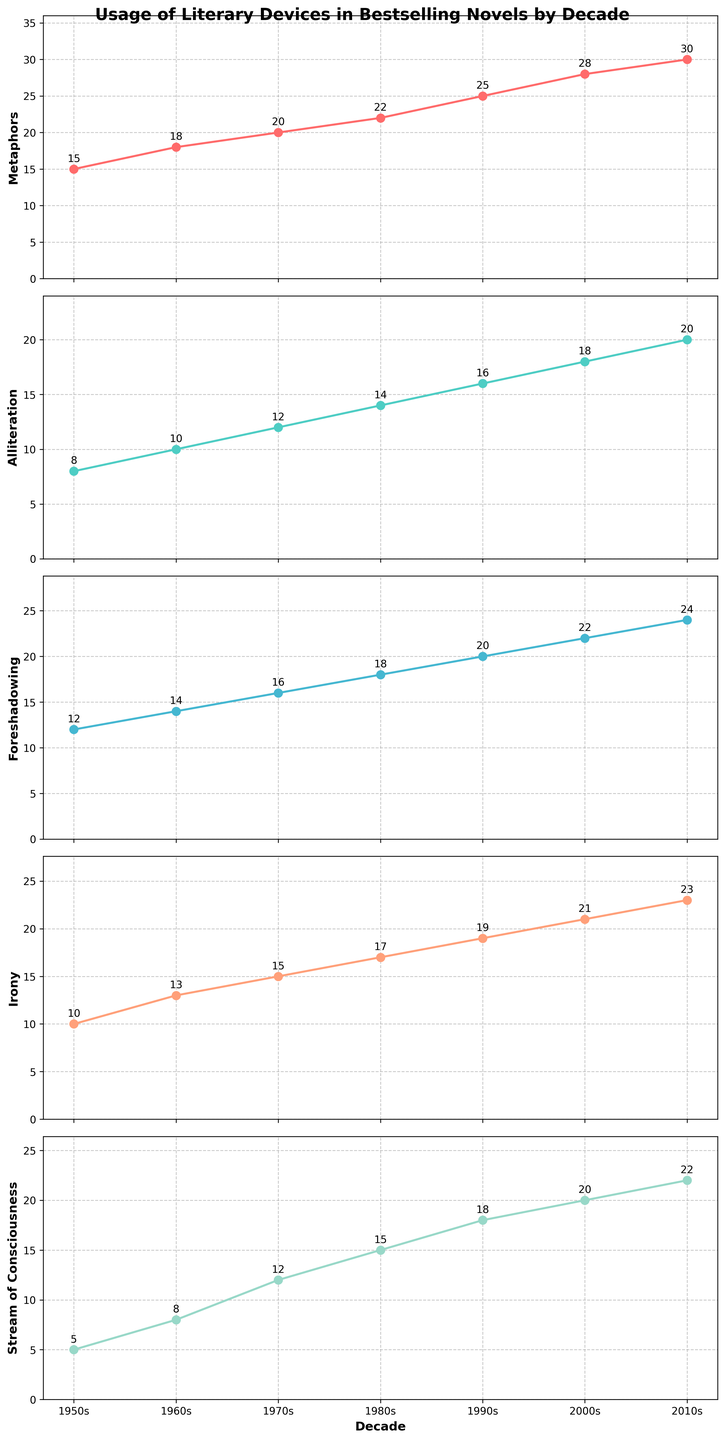What is the title of the figure? The title of the figure is displayed prominently at the top of the plot. It says "Usage of Literary Devices in Bestselling Novels by Decade."
Answer: Usage of Literary Devices in Bestselling Novels by Decade How many subplots are there in the figure? The figure is composed of five distinct vertical subplots stacked on top of each other.
Answer: 5 Which literary device shows the greatest increase between the 1950s and the 2010s? By comparing the values from the 1950s and 2010s in each subplot, we can see that "Metaphors" increased from 15 to 30, "Alliteration" from 8 to 20, "Foreshadowing" from 12 to 24, "Irony" from 10 to 23, and "Stream of Consciousness" from 5 to 22. The greatest increase is 15 (30 - 15), which is for "Metaphors."
Answer: Metaphors What decade shows the highest usage of alliteration? By looking at the "Alliteration" subplot, the line reaches its peak at 20 in the 2010s.
Answer: 2010s In which decade is the difference between the usage of Irony and Metaphors the greatest? To determine this, we need to compare the differences for each decade. The differences are: 1950s (15 - 10 = 5), 1960s (18 - 13 = 5), 1970s (20 - 15 = 5), 1980s (22 - 17 = 5), 1990s (25 - 19 = 6), 2000s (28 - 21 = 7), 2010s (30 - 23 = 7). The greatest difference is in the 2000s and 2010s, both with 7.
Answer: 2000s and 2010s What is the sum of Foreshadowing instances from 1950s to 1980s? Sum the values from the "Foreshadowing" subplot for the 1950s, 1960s, 1970s, and 1980s: 12 + 14 + 16 + 18 = 60.
Answer: 60 Which literary device had the least usage in the 1980s? Inspect the values for the 1980s in each subplot. The values are: Metaphors (22), Alliteration (14), Foreshadowing (18), Irony (17), Stream of Consciousness (15). The smallest value is 14 for Alliteration.
Answer: Alliteration What is the average usage of Stream of Consciousness across all decades? Sum the usage values for "Stream of Consciousness" for all decades and divide by the number of decades: (5 + 8 + 12 + 15 + 18 + 20 + 22) / 7 = 100 / 7 ≈ 14.29.
Answer: 14.29 In the 2000s, which literary device had usage closest to the average of all devices' usages that decade? First, calculate the average usage for the 2000s: (28 + 18 + 22 + 21 + 20) / 5 = 109 / 5 = 21.8. Comparing the individual values to 21.8, "Irony" (21) is the closest.
Answer: Irony How does the usage of Irony in the 1990s compare to the usage of Stream of Consciousness in the 2010s? From the figure, Irony in the 1990s has a value of 19, while Stream of Consciousness in the 2010s has a value of 22. 19 is less than 22.
Answer: Irony in the 1990s is less than Stream of Consciousness in the 2010s 